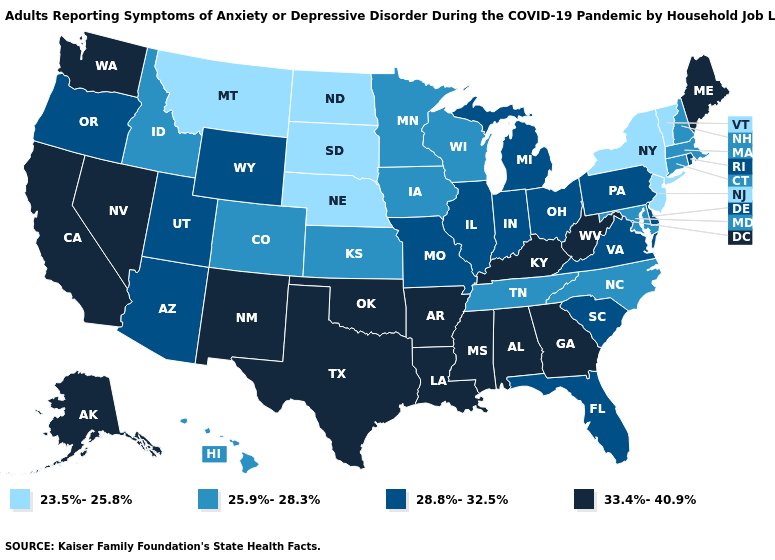What is the value of Montana?
Be succinct. 23.5%-25.8%. Name the states that have a value in the range 28.8%-32.5%?
Write a very short answer. Arizona, Delaware, Florida, Illinois, Indiana, Michigan, Missouri, Ohio, Oregon, Pennsylvania, Rhode Island, South Carolina, Utah, Virginia, Wyoming. What is the value of Florida?
Write a very short answer. 28.8%-32.5%. Name the states that have a value in the range 33.4%-40.9%?
Write a very short answer. Alabama, Alaska, Arkansas, California, Georgia, Kentucky, Louisiana, Maine, Mississippi, Nevada, New Mexico, Oklahoma, Texas, Washington, West Virginia. What is the value of South Dakota?
Short answer required. 23.5%-25.8%. What is the value of Georgia?
Be succinct. 33.4%-40.9%. What is the value of Maine?
Short answer required. 33.4%-40.9%. Among the states that border South Carolina , which have the lowest value?
Keep it brief. North Carolina. Does the map have missing data?
Give a very brief answer. No. Among the states that border Massachusetts , which have the highest value?
Concise answer only. Rhode Island. What is the value of Tennessee?
Give a very brief answer. 25.9%-28.3%. Name the states that have a value in the range 23.5%-25.8%?
Write a very short answer. Montana, Nebraska, New Jersey, New York, North Dakota, South Dakota, Vermont. What is the highest value in states that border Kentucky?
Concise answer only. 33.4%-40.9%. Which states have the lowest value in the South?
Concise answer only. Maryland, North Carolina, Tennessee. What is the lowest value in states that border Kentucky?
Keep it brief. 25.9%-28.3%. 